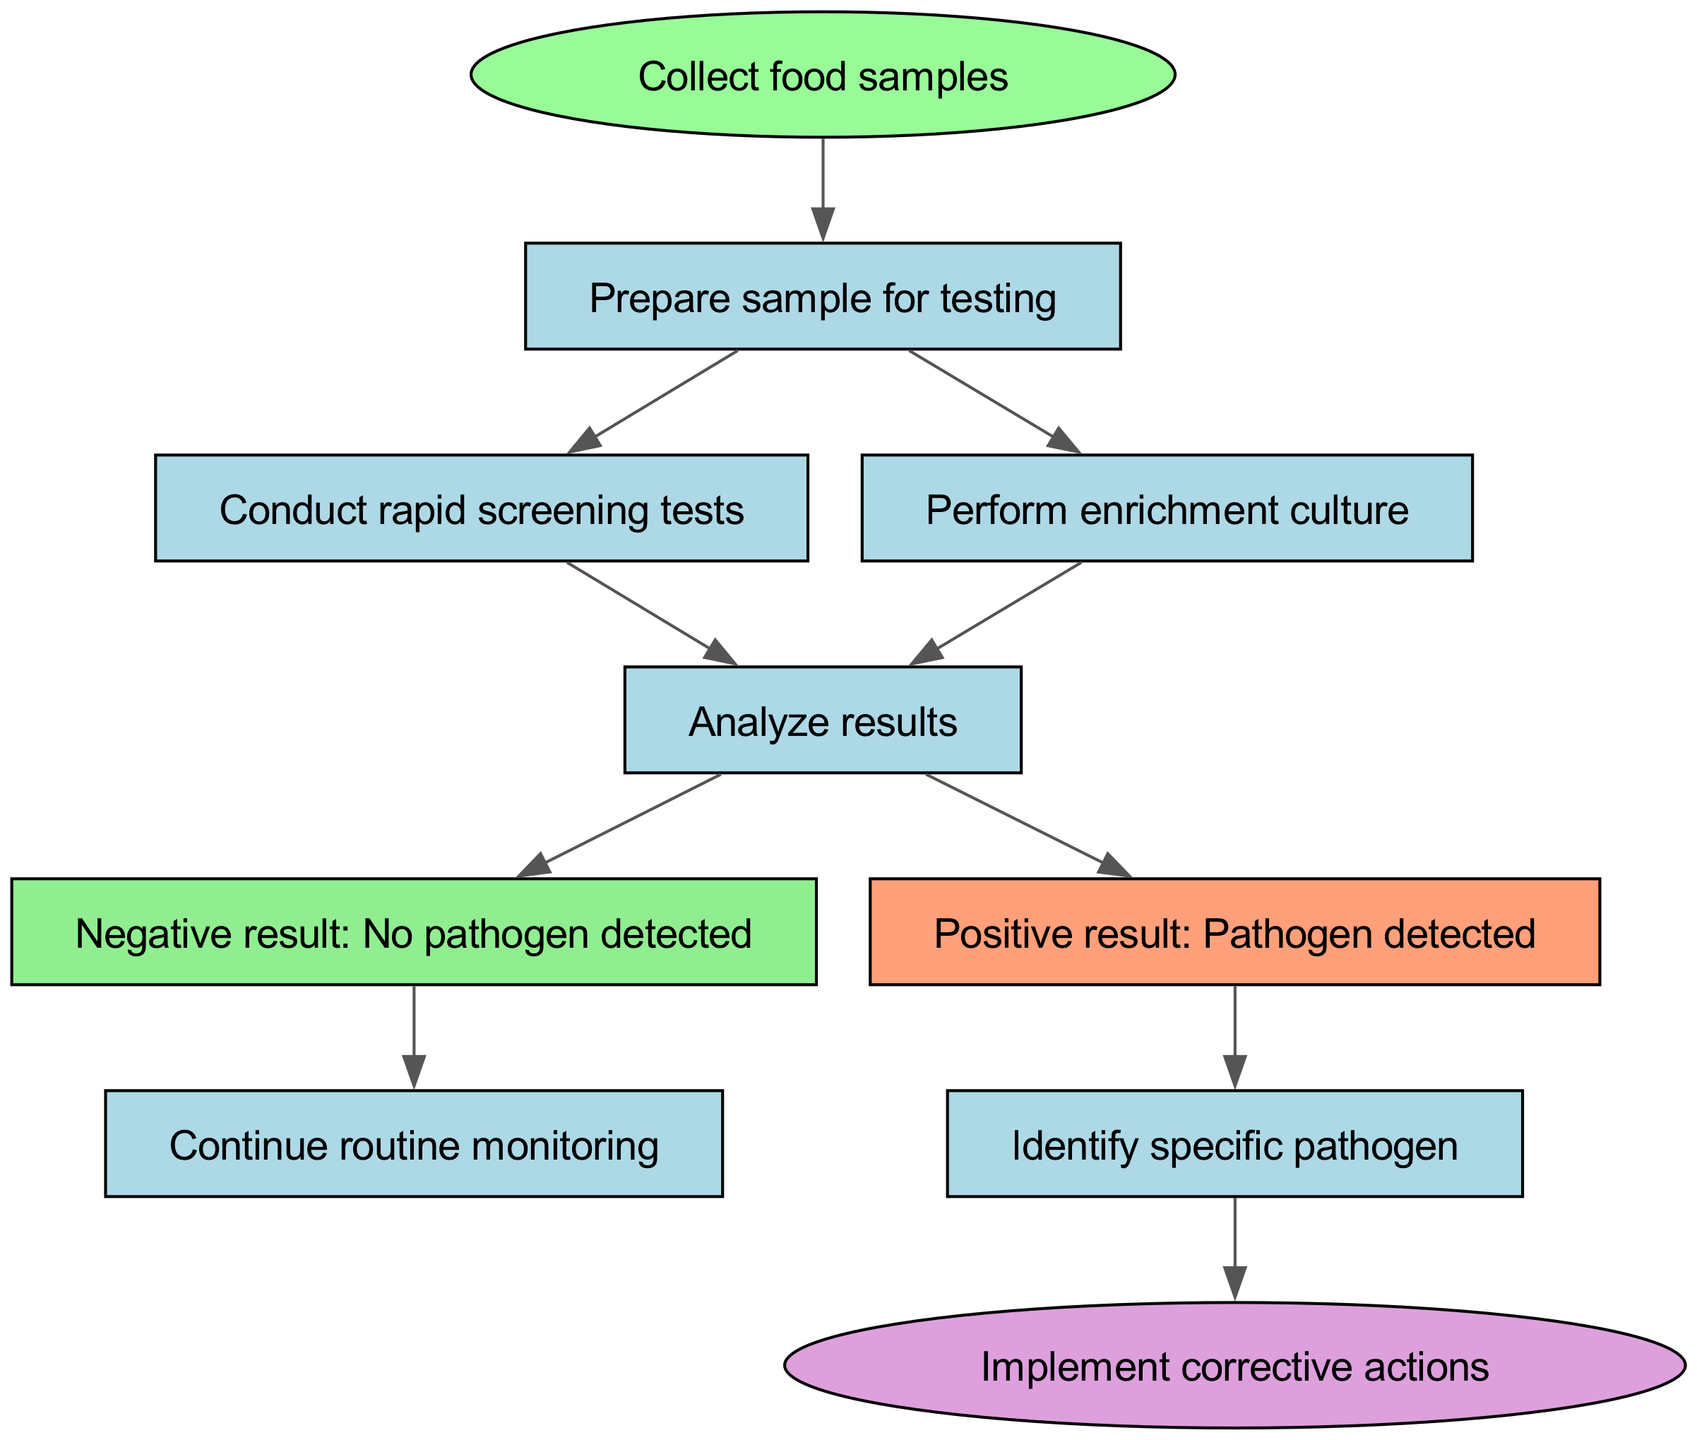What is the start node in the diagram? The start node is explicitly labeled in the diagram and indicates the beginning of the process. According to the data provided, the start node is "Collect food samples."
Answer: Collect food samples How many nodes are present in the diagram? To determine the number of nodes, we count each unique element in the flow chart. The provided data outlines a total of 9 unique nodes, plus the start node, resulting in 10 nodes overall.
Answer: 10 What happens if a negative result is obtained? The process flows from the negative result node, which indicates that "No pathogen detected," leading to the next action. According to the diagram, the next step is to "Continue routine monitoring."
Answer: Continue routine monitoring What is the next step after conducting enrichment culture? Following the "Perform enrichment culture" node, the diagram shows that the next step is to "Analyze results." This step connects to the flow from multiple previous nodes, including the one in question.
Answer: Analyze results What is the color of the node indicating a positive result? The diagram uses specific colors for different types of nodes. The positive result node is labeled "Positive result: Pathogen detected," and it is filled with a light orange color, which is defined in the code.
Answer: Light orange How do you proceed after identifying a specific pathogen? The flow chart leads directly from the "Identify specific pathogen" node to "Implement corrective actions," indicating the next steps in the process after the specific pathogen is identified.
Answer: Implement corrective actions What is the last node in the flow chart? The end of the flow chart is represented by the final action or outcome occurring in the process. The last node is "Implement corrective actions," and it represents the final step in this pathogen testing process.
Answer: Implement corrective actions What is the relationship between conducting rapid screening tests and performing enrichment culture? Both of these actions are connected to the same subsequent node, which is "Analyze results." They can be seen as parallel steps that lead to the same point in the process, indicating an alternative route to testing food samples.
Answer: Analyze results What action comes after a positive result indicating a pathogen detection? The flow indicates that the next required action after a positive result is to "Identify specific pathogen," indicating that further analysis will be conducted to determine which pathogen is present.
Answer: Identify specific pathogen 